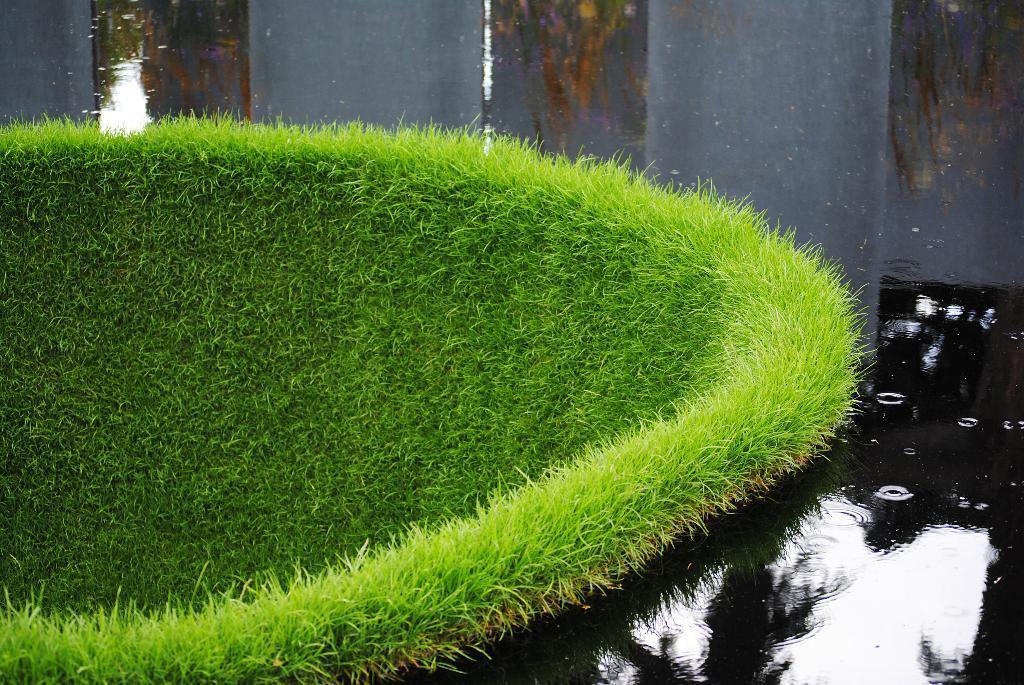Can you describe this image briefly? In this image there is water and we can see grass. 